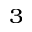Convert formula to latex. <formula><loc_0><loc_0><loc_500><loc_500>_ { 3 }</formula> 